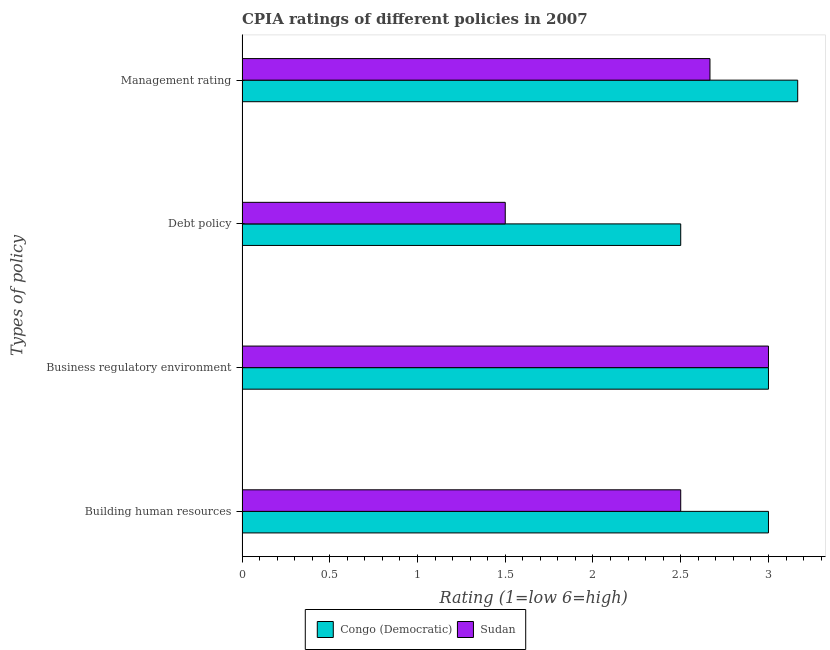How many groups of bars are there?
Give a very brief answer. 4. Are the number of bars per tick equal to the number of legend labels?
Give a very brief answer. Yes. How many bars are there on the 3rd tick from the top?
Ensure brevity in your answer.  2. What is the label of the 1st group of bars from the top?
Ensure brevity in your answer.  Management rating. What is the cpia rating of business regulatory environment in Congo (Democratic)?
Offer a very short reply. 3. Across all countries, what is the maximum cpia rating of building human resources?
Your answer should be compact. 3. In which country was the cpia rating of building human resources maximum?
Your response must be concise. Congo (Democratic). In which country was the cpia rating of debt policy minimum?
Your response must be concise. Sudan. What is the difference between the cpia rating of building human resources in Sudan and that in Congo (Democratic)?
Give a very brief answer. -0.5. What is the average cpia rating of debt policy per country?
Provide a succinct answer. 2. What is the ratio of the cpia rating of management in Congo (Democratic) to that in Sudan?
Ensure brevity in your answer.  1.19. What is the difference between the highest and the second highest cpia rating of business regulatory environment?
Offer a terse response. 0. In how many countries, is the cpia rating of debt policy greater than the average cpia rating of debt policy taken over all countries?
Give a very brief answer. 1. Is the sum of the cpia rating of building human resources in Sudan and Congo (Democratic) greater than the maximum cpia rating of management across all countries?
Give a very brief answer. Yes. What does the 2nd bar from the top in Business regulatory environment represents?
Your answer should be compact. Congo (Democratic). What does the 1st bar from the bottom in Debt policy represents?
Your response must be concise. Congo (Democratic). How many bars are there?
Give a very brief answer. 8. Are all the bars in the graph horizontal?
Provide a succinct answer. Yes. How many countries are there in the graph?
Your response must be concise. 2. What is the difference between two consecutive major ticks on the X-axis?
Provide a succinct answer. 0.5. Are the values on the major ticks of X-axis written in scientific E-notation?
Ensure brevity in your answer.  No. Does the graph contain grids?
Provide a succinct answer. No. How many legend labels are there?
Offer a very short reply. 2. How are the legend labels stacked?
Ensure brevity in your answer.  Horizontal. What is the title of the graph?
Offer a very short reply. CPIA ratings of different policies in 2007. What is the label or title of the Y-axis?
Give a very brief answer. Types of policy. What is the Rating (1=low 6=high) of Congo (Democratic) in Building human resources?
Offer a very short reply. 3. What is the Rating (1=low 6=high) of Sudan in Building human resources?
Your answer should be compact. 2.5. What is the Rating (1=low 6=high) in Congo (Democratic) in Debt policy?
Provide a succinct answer. 2.5. What is the Rating (1=low 6=high) in Congo (Democratic) in Management rating?
Make the answer very short. 3.17. What is the Rating (1=low 6=high) of Sudan in Management rating?
Make the answer very short. 2.67. Across all Types of policy, what is the maximum Rating (1=low 6=high) in Congo (Democratic)?
Offer a very short reply. 3.17. Across all Types of policy, what is the minimum Rating (1=low 6=high) in Congo (Democratic)?
Your answer should be very brief. 2.5. Across all Types of policy, what is the minimum Rating (1=low 6=high) of Sudan?
Keep it short and to the point. 1.5. What is the total Rating (1=low 6=high) in Congo (Democratic) in the graph?
Keep it short and to the point. 11.67. What is the total Rating (1=low 6=high) in Sudan in the graph?
Your answer should be compact. 9.67. What is the difference between the Rating (1=low 6=high) of Sudan in Building human resources and that in Business regulatory environment?
Make the answer very short. -0.5. What is the difference between the Rating (1=low 6=high) in Congo (Democratic) in Building human resources and that in Debt policy?
Keep it short and to the point. 0.5. What is the difference between the Rating (1=low 6=high) in Sudan in Building human resources and that in Debt policy?
Offer a terse response. 1. What is the difference between the Rating (1=low 6=high) in Congo (Democratic) in Building human resources and that in Management rating?
Make the answer very short. -0.17. What is the difference between the Rating (1=low 6=high) of Sudan in Business regulatory environment and that in Debt policy?
Make the answer very short. 1.5. What is the difference between the Rating (1=low 6=high) in Sudan in Business regulatory environment and that in Management rating?
Make the answer very short. 0.33. What is the difference between the Rating (1=low 6=high) of Sudan in Debt policy and that in Management rating?
Offer a very short reply. -1.17. What is the difference between the Rating (1=low 6=high) of Congo (Democratic) in Building human resources and the Rating (1=low 6=high) of Sudan in Management rating?
Provide a succinct answer. 0.33. What is the difference between the Rating (1=low 6=high) of Congo (Democratic) in Debt policy and the Rating (1=low 6=high) of Sudan in Management rating?
Keep it short and to the point. -0.17. What is the average Rating (1=low 6=high) of Congo (Democratic) per Types of policy?
Offer a terse response. 2.92. What is the average Rating (1=low 6=high) of Sudan per Types of policy?
Provide a succinct answer. 2.42. What is the difference between the Rating (1=low 6=high) in Congo (Democratic) and Rating (1=low 6=high) in Sudan in Business regulatory environment?
Keep it short and to the point. 0. What is the ratio of the Rating (1=low 6=high) of Sudan in Building human resources to that in Debt policy?
Give a very brief answer. 1.67. What is the ratio of the Rating (1=low 6=high) of Sudan in Business regulatory environment to that in Debt policy?
Keep it short and to the point. 2. What is the ratio of the Rating (1=low 6=high) of Sudan in Business regulatory environment to that in Management rating?
Provide a succinct answer. 1.12. What is the ratio of the Rating (1=low 6=high) in Congo (Democratic) in Debt policy to that in Management rating?
Offer a terse response. 0.79. What is the ratio of the Rating (1=low 6=high) in Sudan in Debt policy to that in Management rating?
Your response must be concise. 0.56. What is the difference between the highest and the second highest Rating (1=low 6=high) of Sudan?
Offer a very short reply. 0.33. 